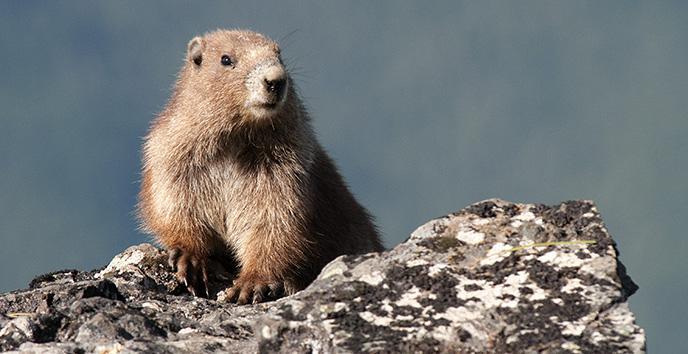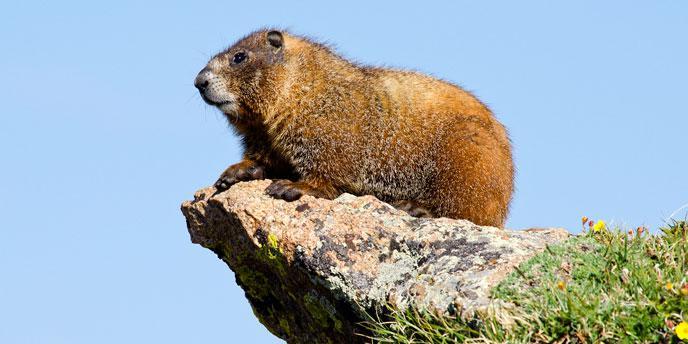The first image is the image on the left, the second image is the image on the right. Assess this claim about the two images: "One imag shows a single marmot with hands together lifted in front of its body.". Correct or not? Answer yes or no. No. The first image is the image on the left, the second image is the image on the right. Evaluate the accuracy of this statement regarding the images: "Two animals are on a rocky ledge.". Is it true? Answer yes or no. Yes. 